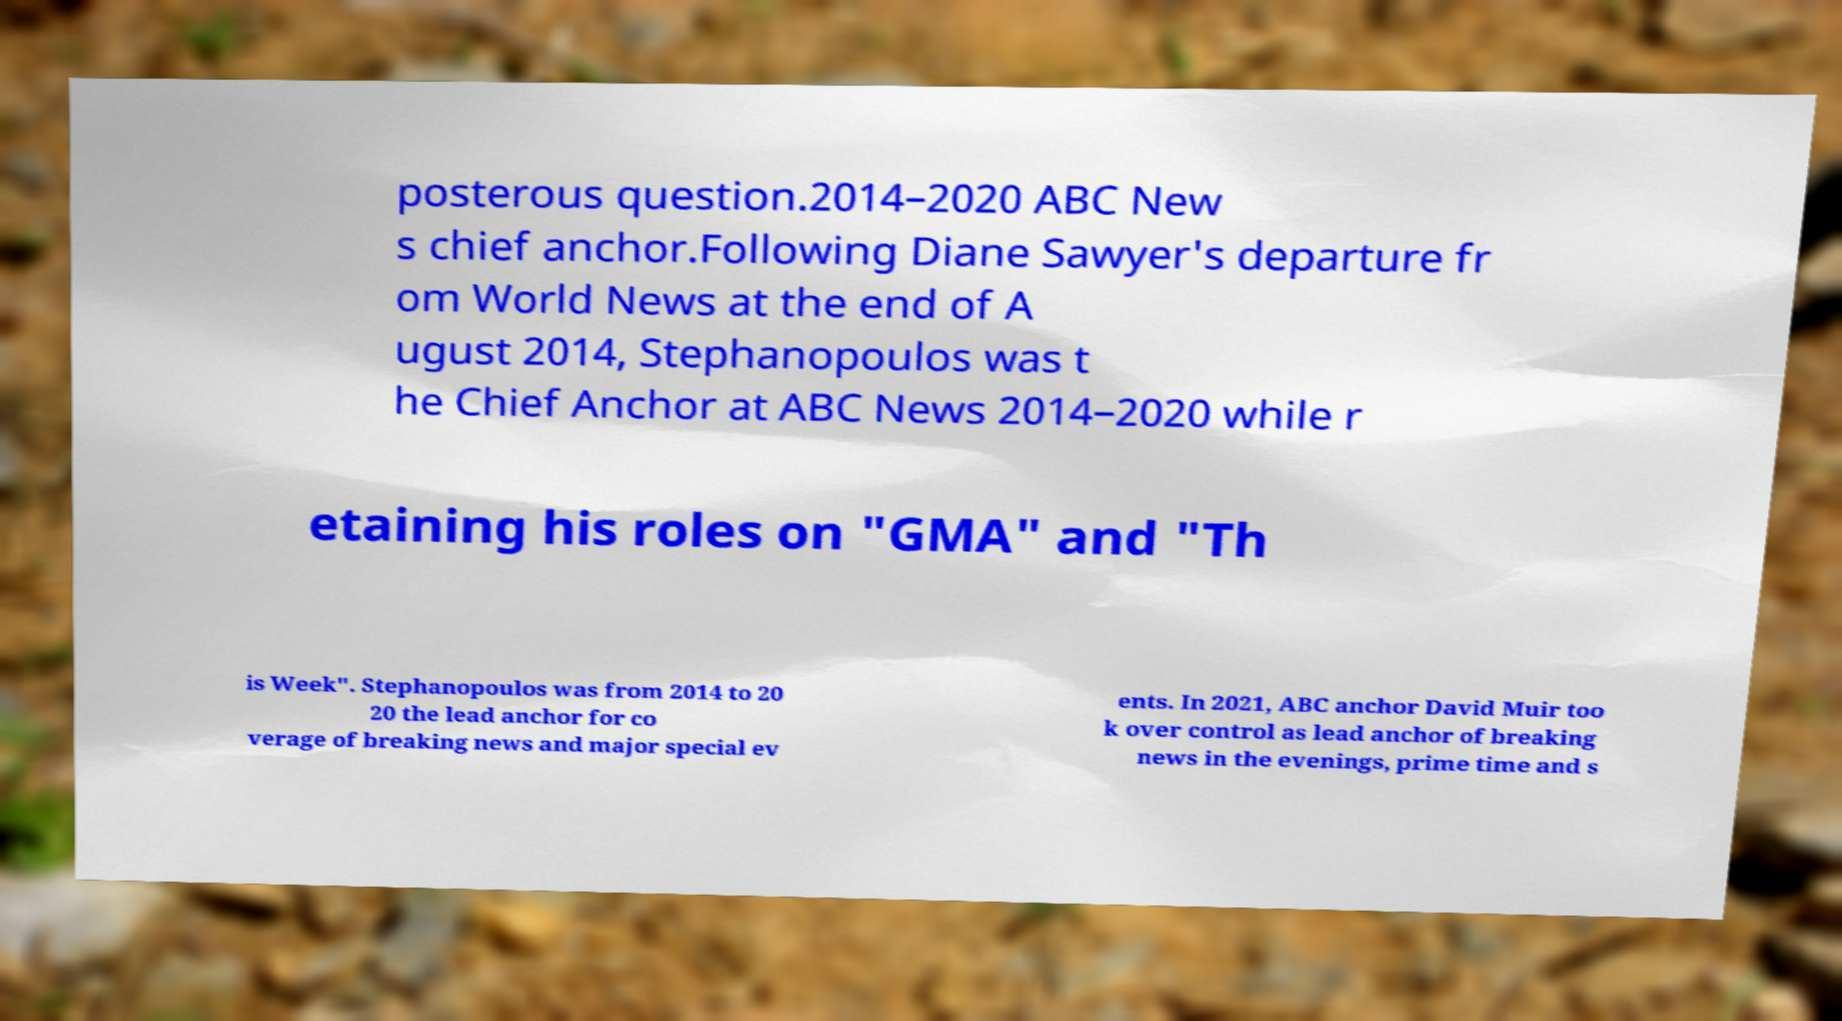There's text embedded in this image that I need extracted. Can you transcribe it verbatim? posterous question.2014–2020 ABC New s chief anchor.Following Diane Sawyer's departure fr om World News at the end of A ugust 2014, Stephanopoulos was t he Chief Anchor at ABC News 2014–2020 while r etaining his roles on "GMA" and "Th is Week". Stephanopoulos was from 2014 to 20 20 the lead anchor for co verage of breaking news and major special ev ents. In 2021, ABC anchor David Muir too k over control as lead anchor of breaking news in the evenings, prime time and s 